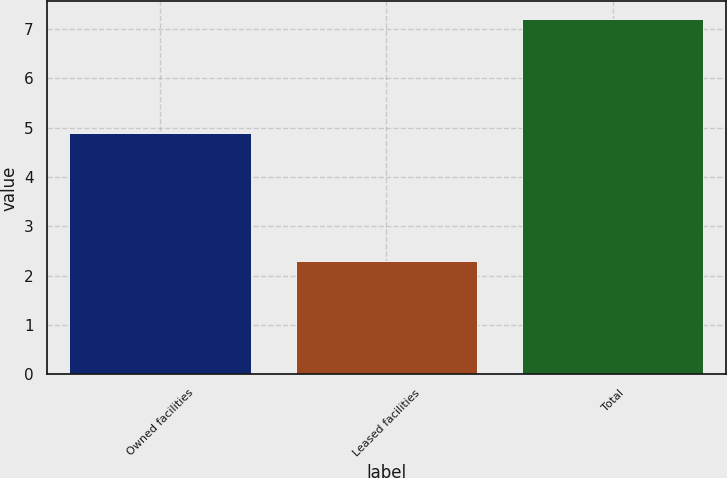Convert chart. <chart><loc_0><loc_0><loc_500><loc_500><bar_chart><fcel>Owned facilities<fcel>Leased facilities<fcel>Total<nl><fcel>4.9<fcel>2.3<fcel>7.2<nl></chart> 